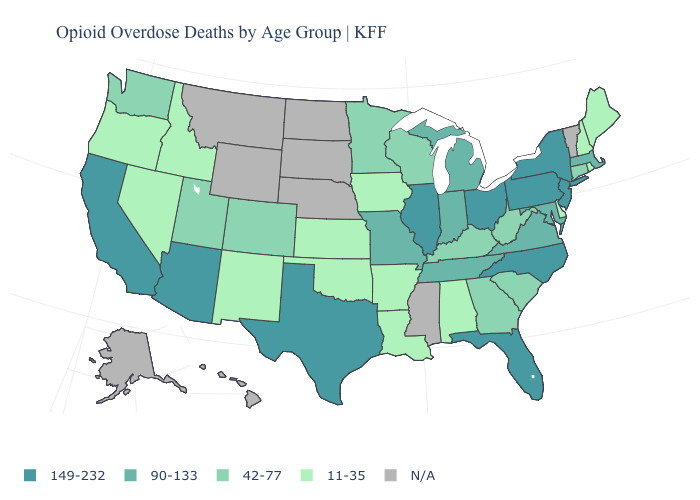Which states have the highest value in the USA?
Write a very short answer. Arizona, California, Florida, Illinois, New Jersey, New York, North Carolina, Ohio, Pennsylvania, Texas. Which states have the highest value in the USA?
Be succinct. Arizona, California, Florida, Illinois, New Jersey, New York, North Carolina, Ohio, Pennsylvania, Texas. Name the states that have a value in the range N/A?
Answer briefly. Alaska, Hawaii, Mississippi, Montana, Nebraska, North Dakota, South Dakota, Vermont, Wyoming. Name the states that have a value in the range 42-77?
Give a very brief answer. Colorado, Connecticut, Georgia, Kentucky, Minnesota, South Carolina, Utah, Washington, West Virginia, Wisconsin. Does the first symbol in the legend represent the smallest category?
Concise answer only. No. Name the states that have a value in the range 149-232?
Keep it brief. Arizona, California, Florida, Illinois, New Jersey, New York, North Carolina, Ohio, Pennsylvania, Texas. What is the lowest value in the USA?
Be succinct. 11-35. What is the value of Alabama?
Be succinct. 11-35. Is the legend a continuous bar?
Quick response, please. No. Which states have the highest value in the USA?
Write a very short answer. Arizona, California, Florida, Illinois, New Jersey, New York, North Carolina, Ohio, Pennsylvania, Texas. What is the value of Colorado?
Short answer required. 42-77. What is the value of Maine?
Give a very brief answer. 11-35. Is the legend a continuous bar?
Give a very brief answer. No. Does South Carolina have the lowest value in the South?
Quick response, please. No. Name the states that have a value in the range N/A?
Concise answer only. Alaska, Hawaii, Mississippi, Montana, Nebraska, North Dakota, South Dakota, Vermont, Wyoming. 